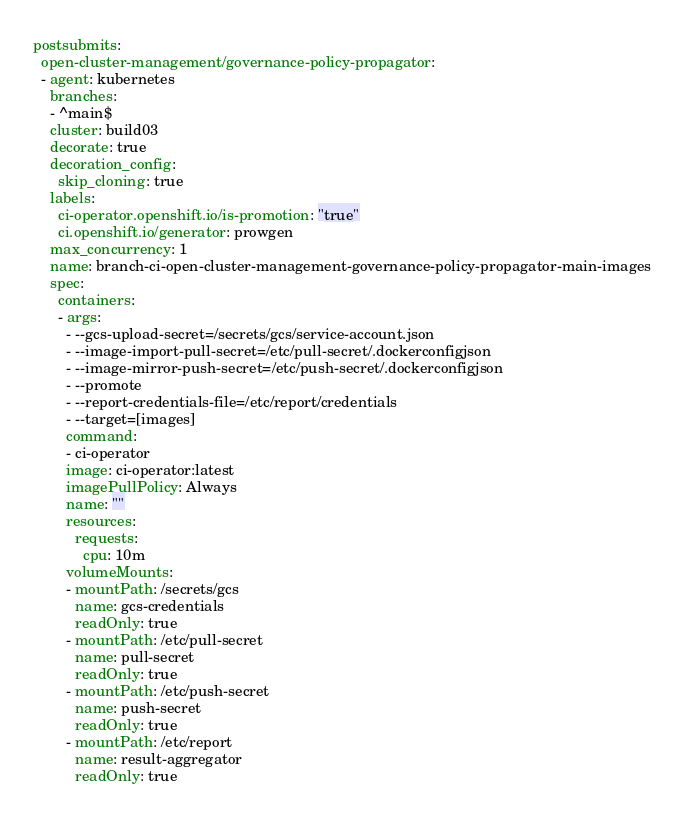Convert code to text. <code><loc_0><loc_0><loc_500><loc_500><_YAML_>postsubmits:
  open-cluster-management/governance-policy-propagator:
  - agent: kubernetes
    branches:
    - ^main$
    cluster: build03
    decorate: true
    decoration_config:
      skip_cloning: true
    labels:
      ci-operator.openshift.io/is-promotion: "true"
      ci.openshift.io/generator: prowgen
    max_concurrency: 1
    name: branch-ci-open-cluster-management-governance-policy-propagator-main-images
    spec:
      containers:
      - args:
        - --gcs-upload-secret=/secrets/gcs/service-account.json
        - --image-import-pull-secret=/etc/pull-secret/.dockerconfigjson
        - --image-mirror-push-secret=/etc/push-secret/.dockerconfigjson
        - --promote
        - --report-credentials-file=/etc/report/credentials
        - --target=[images]
        command:
        - ci-operator
        image: ci-operator:latest
        imagePullPolicy: Always
        name: ""
        resources:
          requests:
            cpu: 10m
        volumeMounts:
        - mountPath: /secrets/gcs
          name: gcs-credentials
          readOnly: true
        - mountPath: /etc/pull-secret
          name: pull-secret
          readOnly: true
        - mountPath: /etc/push-secret
          name: push-secret
          readOnly: true
        - mountPath: /etc/report
          name: result-aggregator
          readOnly: true</code> 